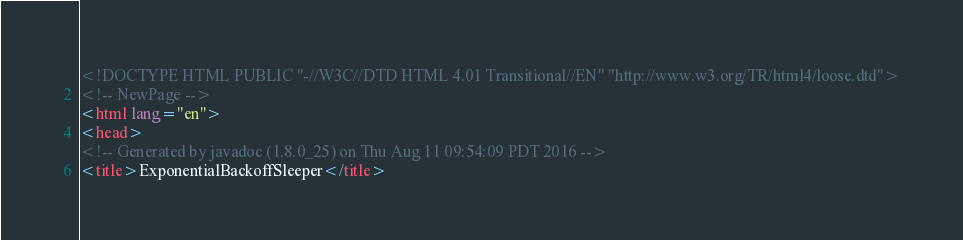<code> <loc_0><loc_0><loc_500><loc_500><_HTML_><!DOCTYPE HTML PUBLIC "-//W3C//DTD HTML 4.01 Transitional//EN" "http://www.w3.org/TR/html4/loose.dtd">
<!-- NewPage -->
<html lang="en">
<head>
<!-- Generated by javadoc (1.8.0_25) on Thu Aug 11 09:54:09 PDT 2016 -->
<title>ExponentialBackoffSleeper</title></code> 